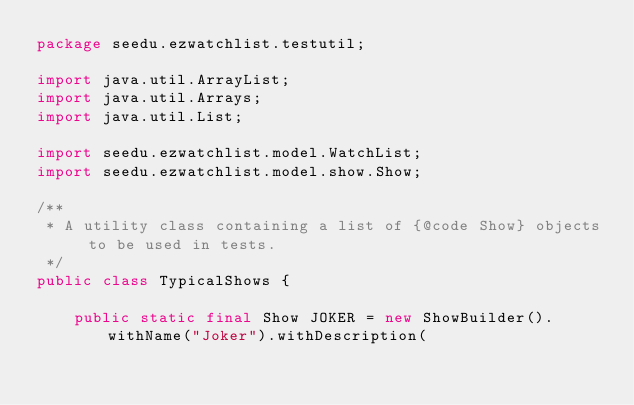<code> <loc_0><loc_0><loc_500><loc_500><_Java_>package seedu.ezwatchlist.testutil;

import java.util.ArrayList;
import java.util.Arrays;
import java.util.List;

import seedu.ezwatchlist.model.WatchList;
import seedu.ezwatchlist.model.show.Show;

/**
 * A utility class containing a list of {@code Show} objects to be used in tests.
 */
public class TypicalShows {

    public static final Show JOKER = new ShowBuilder().withName("Joker").withDescription(</code> 